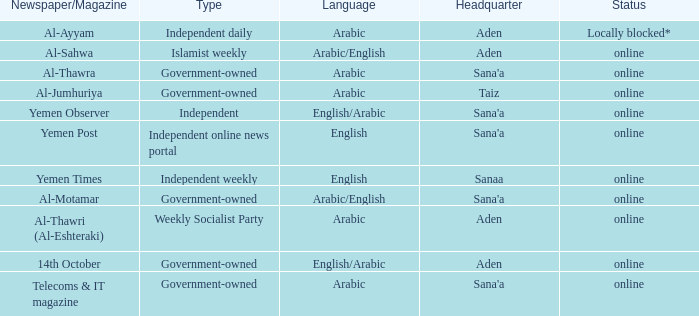When referring to al-jumhuriya, a government-owned newspaper/magazine, where is its head office situated? Taiz. 